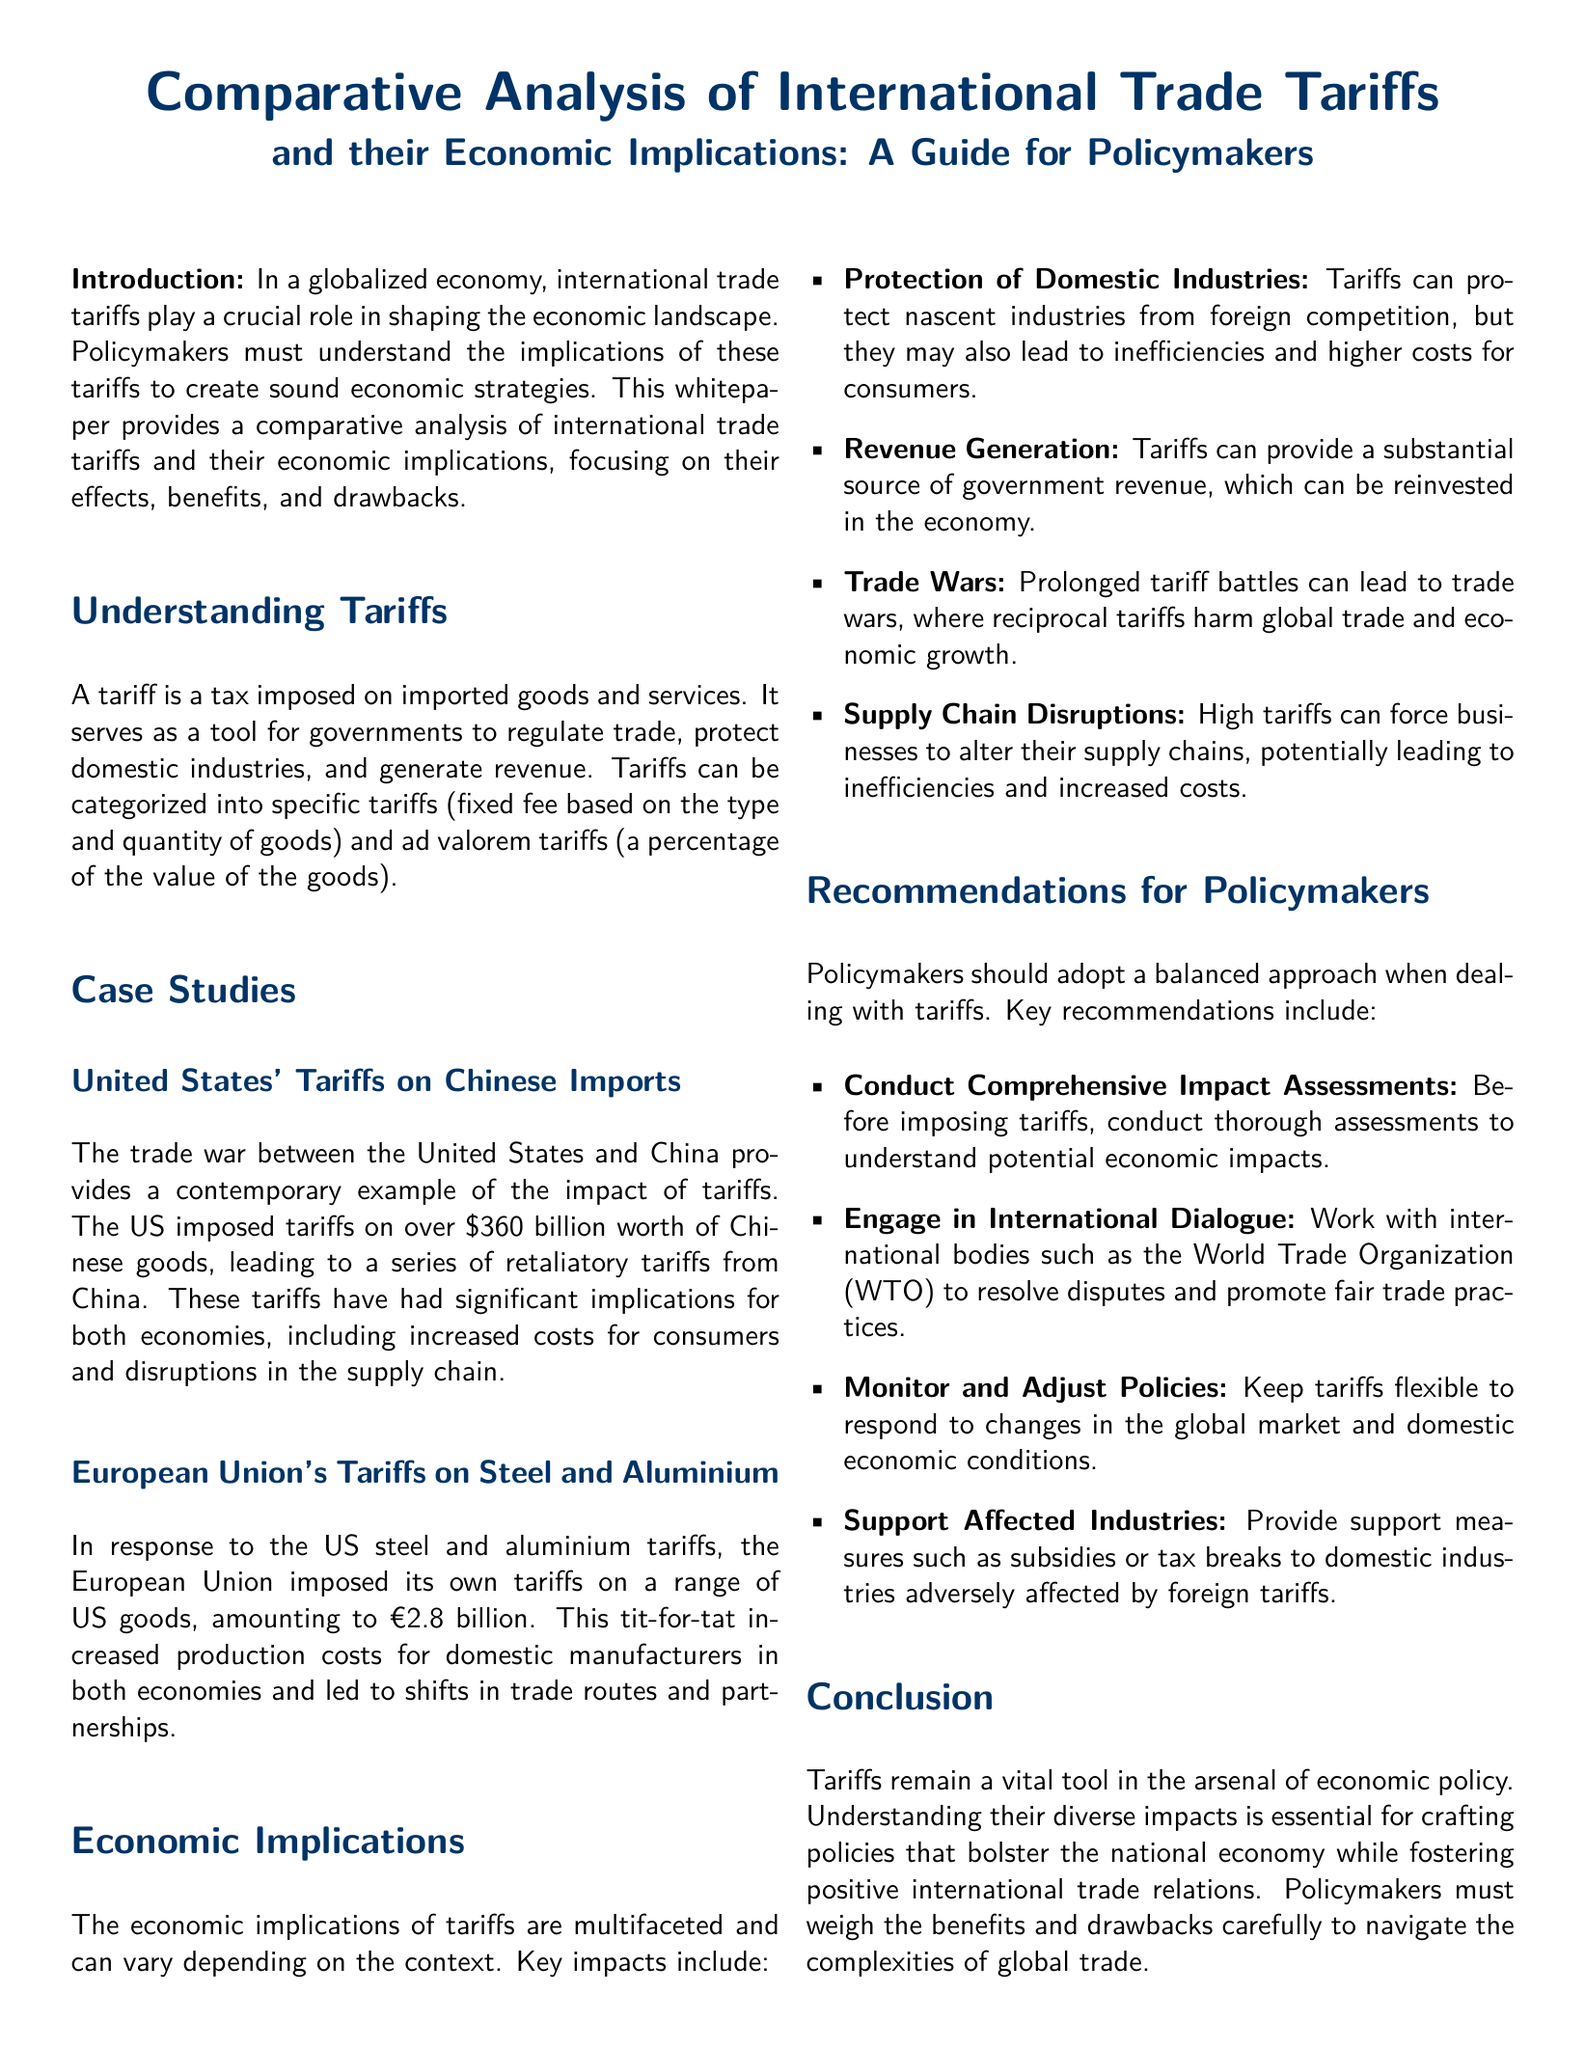What is the primary focus of the whitepaper? The primary focus of the whitepaper is a comparative analysis of international trade tariffs and their economic implications.
Answer: comparative analysis of international trade tariffs and their economic implications What are the two categories of tariffs mentioned? The two categories of tariffs mentioned are specific tariffs and ad valorem tariffs.
Answer: specific tariffs and ad valorem tariffs What was the value of Chinese goods subject to US tariffs? The value of Chinese goods subject to US tariffs was over $360 billion.
Answer: over $360 billion What is one key recommendation for policymakers? One key recommendation for policymakers is to conduct comprehensive impact assessments.
Answer: conduct comprehensive impact assessments What economic effect can tariffs have on domestic industries? Tariffs can protect nascent industries from foreign competition.
Answer: protect nascent industries from foreign competition Which international organization is mentioned for resolving trade disputes? The international organization mentioned for resolving trade disputes is the World Trade Organization (WTO).
Answer: World Trade Organization (WTO) What is a potential consequence of prolonged tariff battles? A potential consequence of prolonged tariff battles is trade wars.
Answer: trade wars What amount did the European Union impose in response to US tariffs? The amount imposed by the European Union in response to US tariffs was €2.8 billion.
Answer: €2.8 billion 